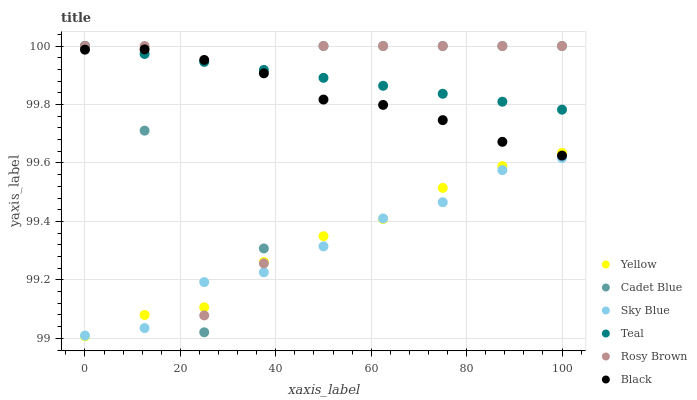Does Sky Blue have the minimum area under the curve?
Answer yes or no. Yes. Does Teal have the maximum area under the curve?
Answer yes or no. Yes. Does Rosy Brown have the minimum area under the curve?
Answer yes or no. No. Does Rosy Brown have the maximum area under the curve?
Answer yes or no. No. Is Teal the smoothest?
Answer yes or no. Yes. Is Rosy Brown the roughest?
Answer yes or no. Yes. Is Yellow the smoothest?
Answer yes or no. No. Is Yellow the roughest?
Answer yes or no. No. Does Yellow have the lowest value?
Answer yes or no. Yes. Does Rosy Brown have the lowest value?
Answer yes or no. No. Does Teal have the highest value?
Answer yes or no. Yes. Does Yellow have the highest value?
Answer yes or no. No. Is Yellow less than Teal?
Answer yes or no. Yes. Is Teal greater than Yellow?
Answer yes or no. Yes. Does Teal intersect Rosy Brown?
Answer yes or no. Yes. Is Teal less than Rosy Brown?
Answer yes or no. No. Is Teal greater than Rosy Brown?
Answer yes or no. No. Does Yellow intersect Teal?
Answer yes or no. No. 